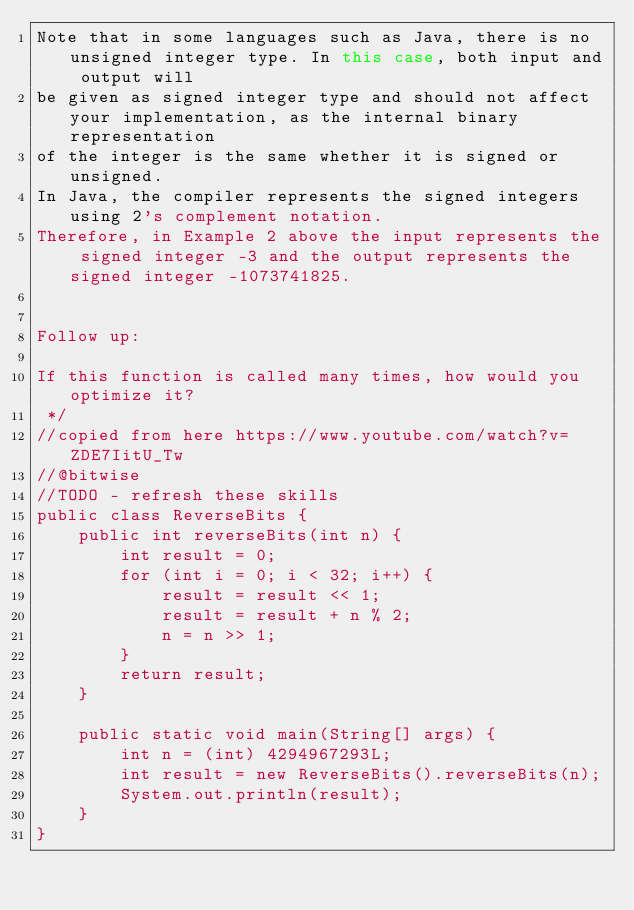<code> <loc_0><loc_0><loc_500><loc_500><_Java_>Note that in some languages such as Java, there is no unsigned integer type. In this case, both input and output will
be given as signed integer type and should not affect your implementation, as the internal binary representation
of the integer is the same whether it is signed or unsigned.
In Java, the compiler represents the signed integers using 2's complement notation.
Therefore, in Example 2 above the input represents the signed integer -3 and the output represents the signed integer -1073741825.


Follow up:

If this function is called many times, how would you optimize it?
 */
//copied from here https://www.youtube.com/watch?v=ZDE7IitU_Tw
//@bitwise
//TODO - refresh these skills
public class ReverseBits {
    public int reverseBits(int n) {
        int result = 0;
        for (int i = 0; i < 32; i++) {
            result = result << 1;
            result = result + n % 2;
            n = n >> 1;
        }
        return result;
    }

    public static void main(String[] args) {
        int n = (int) 4294967293L;
        int result = new ReverseBits().reverseBits(n);
        System.out.println(result);
    }
}
</code> 